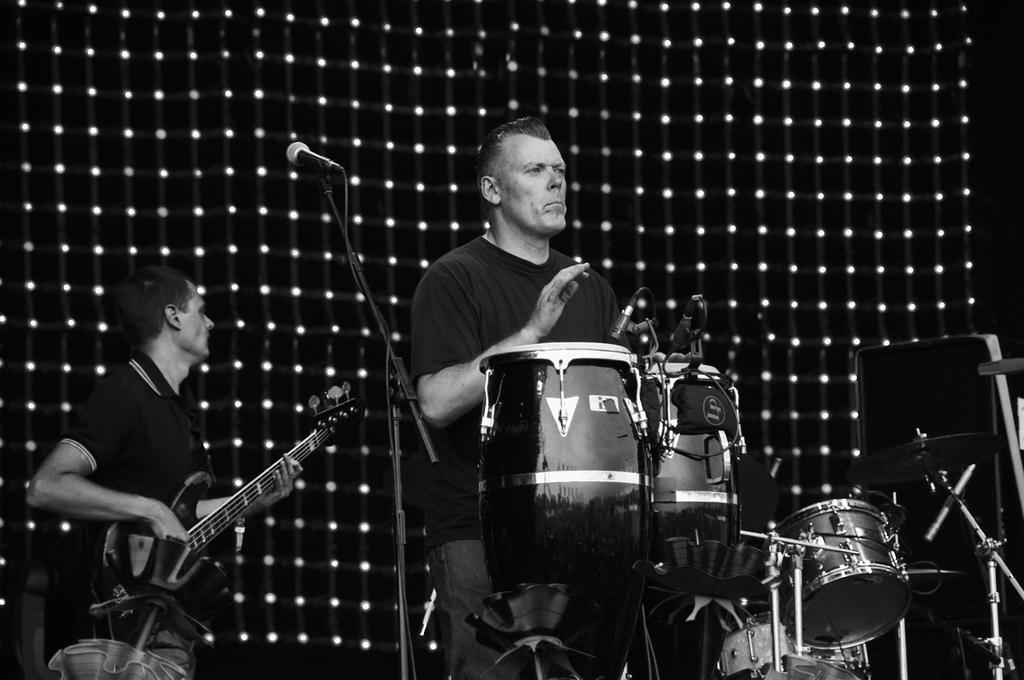What is the person in the image doing? The person is playing drums. What else can be seen in the image related to music? There are microphone stands and a guitar being played by another person. What instrument is the person playing drums for? There is a drum set in the image. What can be seen on the wall in the background? The wall has black and white dots in the background. What type of pan is being used to create the sound effects in the image? There is no pan or sound effects present in the image; it features people playing drums and guitar. 